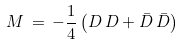Convert formula to latex. <formula><loc_0><loc_0><loc_500><loc_500>M \, = \, - \frac { 1 } { 4 } \left ( D \, D + \bar { D } \, \bar { D } \right )</formula> 